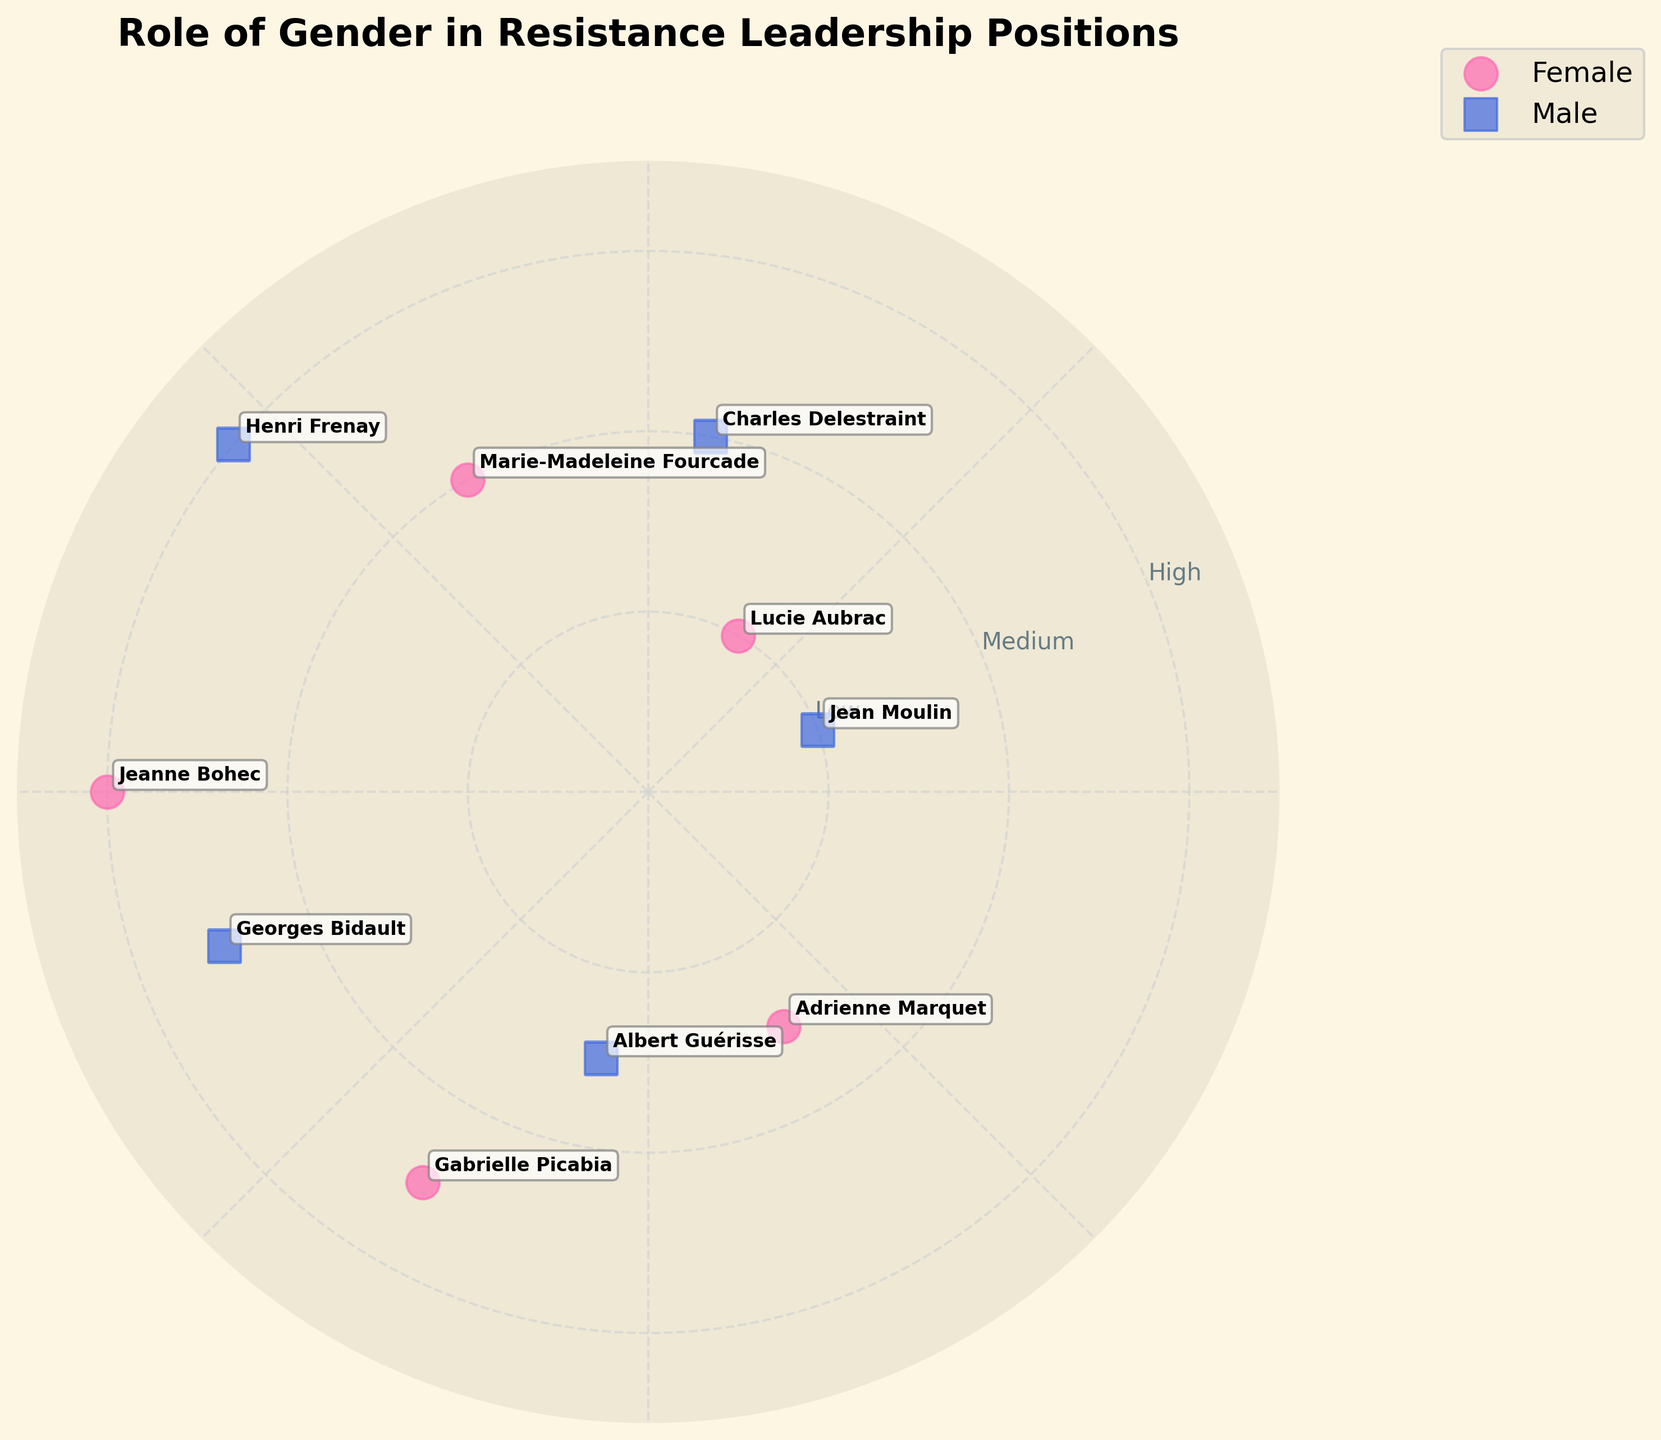What is the title of the plot? The title of the plot is displayed at the top of the figure, it reads "Role of Gender in Resistance Leadership Positions".
Answer: Role of Gender in Resistance Leadership Positions How many male leaders are depicted in the chart? Male leaders are represented by squares (blue markers). By counting the blue squares, we see there are 5 male leaders.
Answer: 5 Which female leader has the highest radial value? To find the female leader with the highest radial value, look for the pink circle markers and identify the one placed the farthest from the center. Jeanne Bohec, with a radial value of 3, is the farthest.
Answer: Jeanne Bohec Between Georges Bidault and Adrienne Marquet, who has a higher radial value? Georges Bidault (male, blue square) has a radial value of 2.5, and Adrienne Marquet (female, pink circle) has a radial value of 1.5. 2.5 is greater than 1.5, so Georges Bidault has a higher radial value.
Answer: Georges Bidault What radial values do Charles Delestraint and Marie-Madeleine Fourcade have? Charles Delestraint (male, blue square) is at a radial value of 2, and Marie-Madeleine Fourcade (female, pink circle) is also at a radial value of 2. Both share the same radial value of 2.
Answer: 2 What is the average radial value of female leaders? Female leaders have radial values of 1 (Lucie Aubrac), 2 (Marie-Madeleine Fourcade), 3 (Jeanne Bohec), 2.5 (Gabrielle Picabia), and 1.5 (Adrienne Marquet). To find the average: (1 + 2 + 3 + 2.5 + 1.5) / 5 = 10 / 5 = 2.
Answer: 2 Which quadrant has the highest concentration of female leaders? The polar scatter chart is divided into four quadrants by the angles. Count the female leaders in each quadrant: 1 in the first (60 degrees), 1 in the second (120 degrees), 1 in the third (240 degrees), and 2 in the fourth (300 degrees, 20 degrees). The fourth quadrant has the highest concentration.
Answer: Fourth quadrant Do any leaders of different genders share the same radial value? Check for overlapping radial values between pink circles (female) and blue squares (male). Both Charles Delestraint and Marie-Madeleine Fourcade have a radial value of 2, indicating shared values.
Answer: Yes Which male leader is positioned at the highest angle? Among the male leaders, the one with the highest angle is Georges Bidault. His marker is placed at an angle of 200 degrees.
Answer: Georges Bidault 